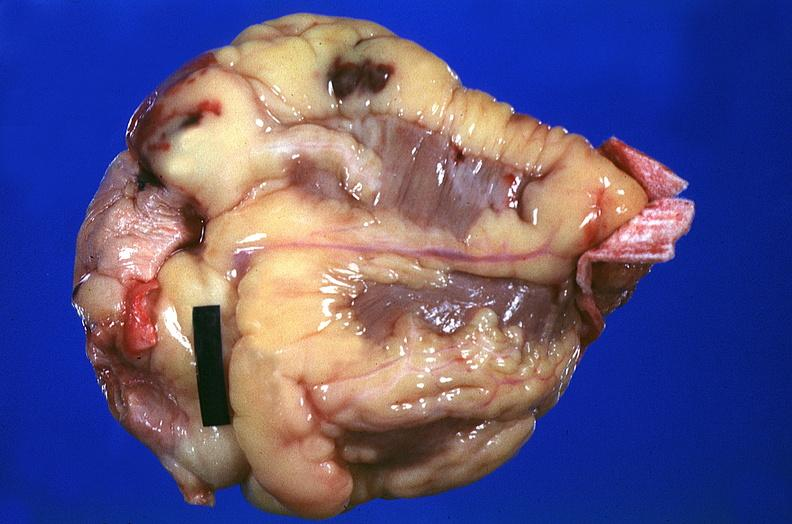does this image show heart, myocardial infarction, surgery to repair interventricular septum rupture?
Answer the question using a single word or phrase. Yes 